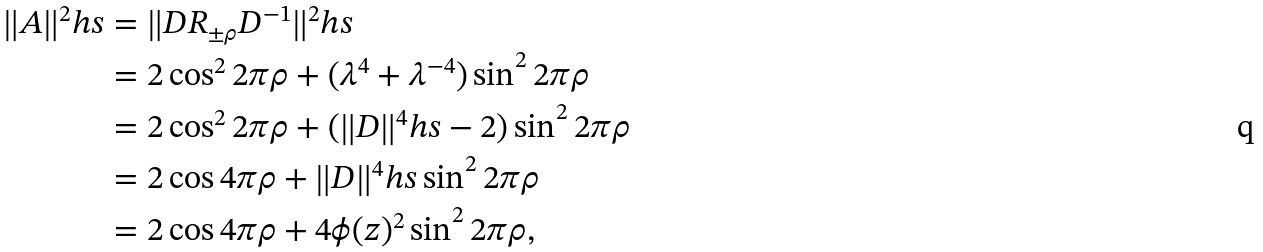Convert formula to latex. <formula><loc_0><loc_0><loc_500><loc_500>\| A \| ^ { 2 } _ { \ } h s & = \| D R _ { \pm \rho } D ^ { - 1 } \| ^ { 2 } _ { \ } h s \\ & = 2 \cos ^ { 2 } 2 \pi \rho + ( \lambda ^ { 4 } + \lambda ^ { - 4 } ) \sin ^ { 2 } 2 \pi \rho \\ & = 2 \cos ^ { 2 } 2 \pi \rho + ( \| D \| ^ { 4 } _ { \ } h s - 2 ) \sin ^ { 2 } 2 \pi \rho \\ & = 2 \cos 4 \pi \rho + \| D \| ^ { 4 } _ { \ } h s \sin ^ { 2 } 2 \pi \rho \\ & = 2 \cos 4 \pi \rho + 4 \phi ( z ) ^ { 2 } \sin ^ { 2 } 2 \pi \rho ,</formula> 